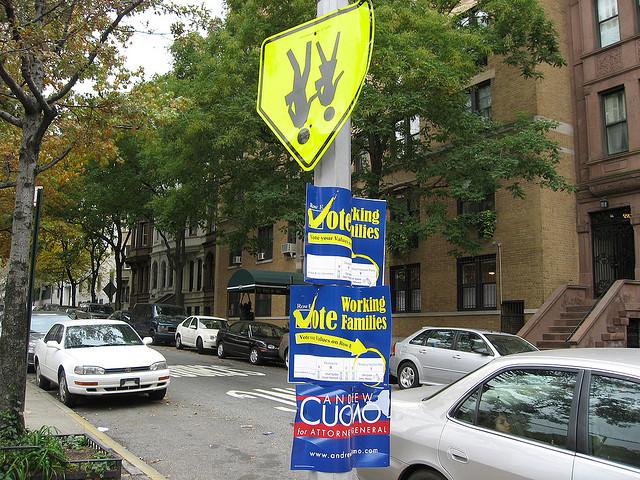Is the sign in its original position?
Quick response, please. No. What does the yellow sign symbolize?
Give a very brief answer. Crosswalk. Is the yellow sign upside down?
Answer briefly. Yes. 